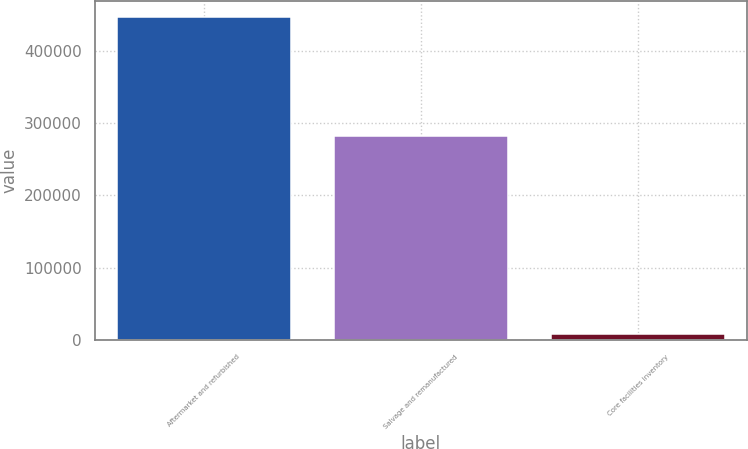Convert chart to OTSL. <chart><loc_0><loc_0><loc_500><loc_500><bar_chart><fcel>Aftermarket and refurbished<fcel>Salvage and remanufactured<fcel>Core facilities inventory<nl><fcel>445787<fcel>282106<fcel>8953<nl></chart> 